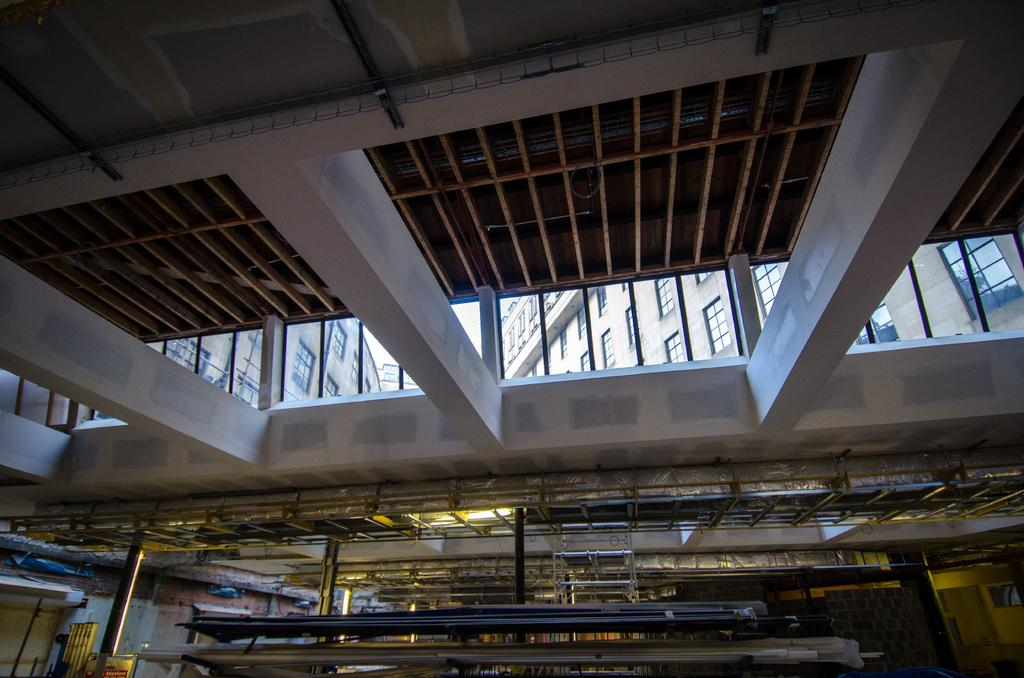What type of location is depicted in the image? The image shows an inside view of a building. What can be seen at the bottom of the image? There are metal rods at the bottom of the image. What is visible in the background of the image? There are buildings visible in the background of the image. What type of food is the stranger holding in the image? There is no stranger or food present in the image. 